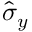Convert formula to latex. <formula><loc_0><loc_0><loc_500><loc_500>\hat { \sigma } _ { y }</formula> 